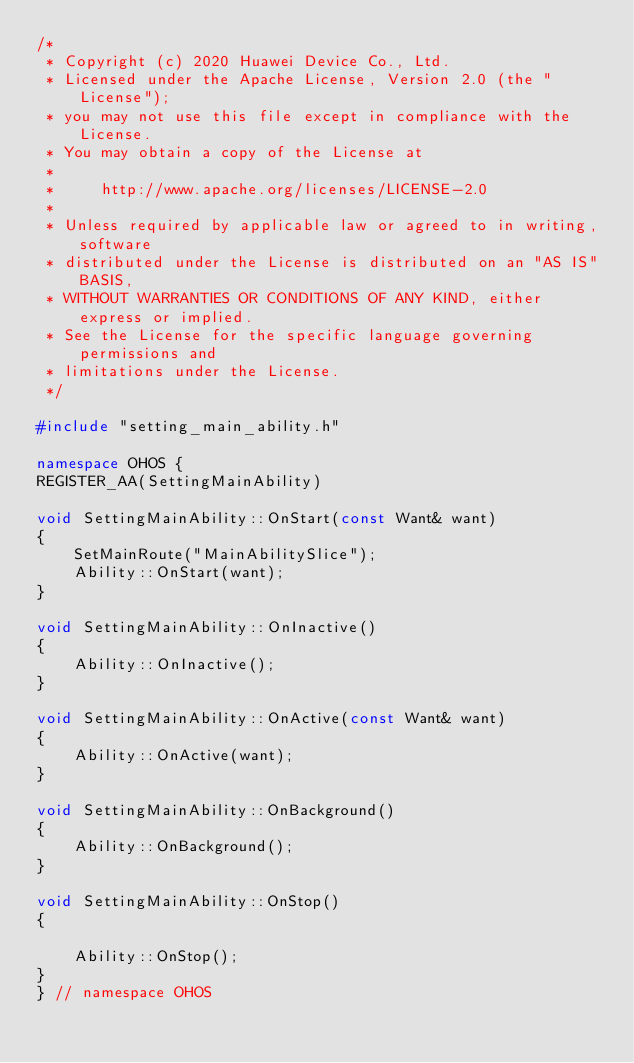<code> <loc_0><loc_0><loc_500><loc_500><_C++_>/*
 * Copyright (c) 2020 Huawei Device Co., Ltd.
 * Licensed under the Apache License, Version 2.0 (the "License");
 * you may not use this file except in compliance with the License.
 * You may obtain a copy of the License at
 *
 *     http://www.apache.org/licenses/LICENSE-2.0
 *
 * Unless required by applicable law or agreed to in writing, software
 * distributed under the License is distributed on an "AS IS" BASIS,
 * WITHOUT WARRANTIES OR CONDITIONS OF ANY KIND, either express or implied.
 * See the License for the specific language governing permissions and
 * limitations under the License.
 */

#include "setting_main_ability.h"

namespace OHOS {
REGISTER_AA(SettingMainAbility)

void SettingMainAbility::OnStart(const Want& want)
{
    SetMainRoute("MainAbilitySlice");
    Ability::OnStart(want);
}

void SettingMainAbility::OnInactive()
{
    Ability::OnInactive();
}

void SettingMainAbility::OnActive(const Want& want)
{
    Ability::OnActive(want);
}

void SettingMainAbility::OnBackground()
{
    Ability::OnBackground();
}

void SettingMainAbility::OnStop()
{

    Ability::OnStop();
}
} // namespace OHOS</code> 